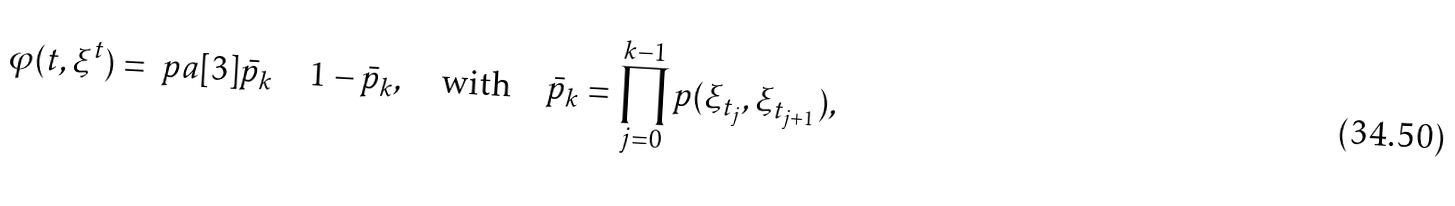Convert formula to latex. <formula><loc_0><loc_0><loc_500><loc_500>\varphi ( t , \xi ^ { t } ) = \ p a [ 3 ] { \bar { p } _ { k } \quad 1 - \bar { p } _ { k } } , \quad \text {with} \quad \bar { p } _ { k } = \prod _ { j = 0 } ^ { k - 1 } p ( \xi _ { t _ { j } } , \xi _ { t _ { j + 1 } } ) ,</formula> 